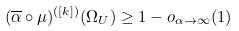Convert formula to latex. <formula><loc_0><loc_0><loc_500><loc_500>( \overline { \alpha } \circ \mu ) ^ { ( [ k ] ) } ( \Omega _ { U } ) \geq 1 - o _ { \alpha \to \infty } ( 1 )</formula> 